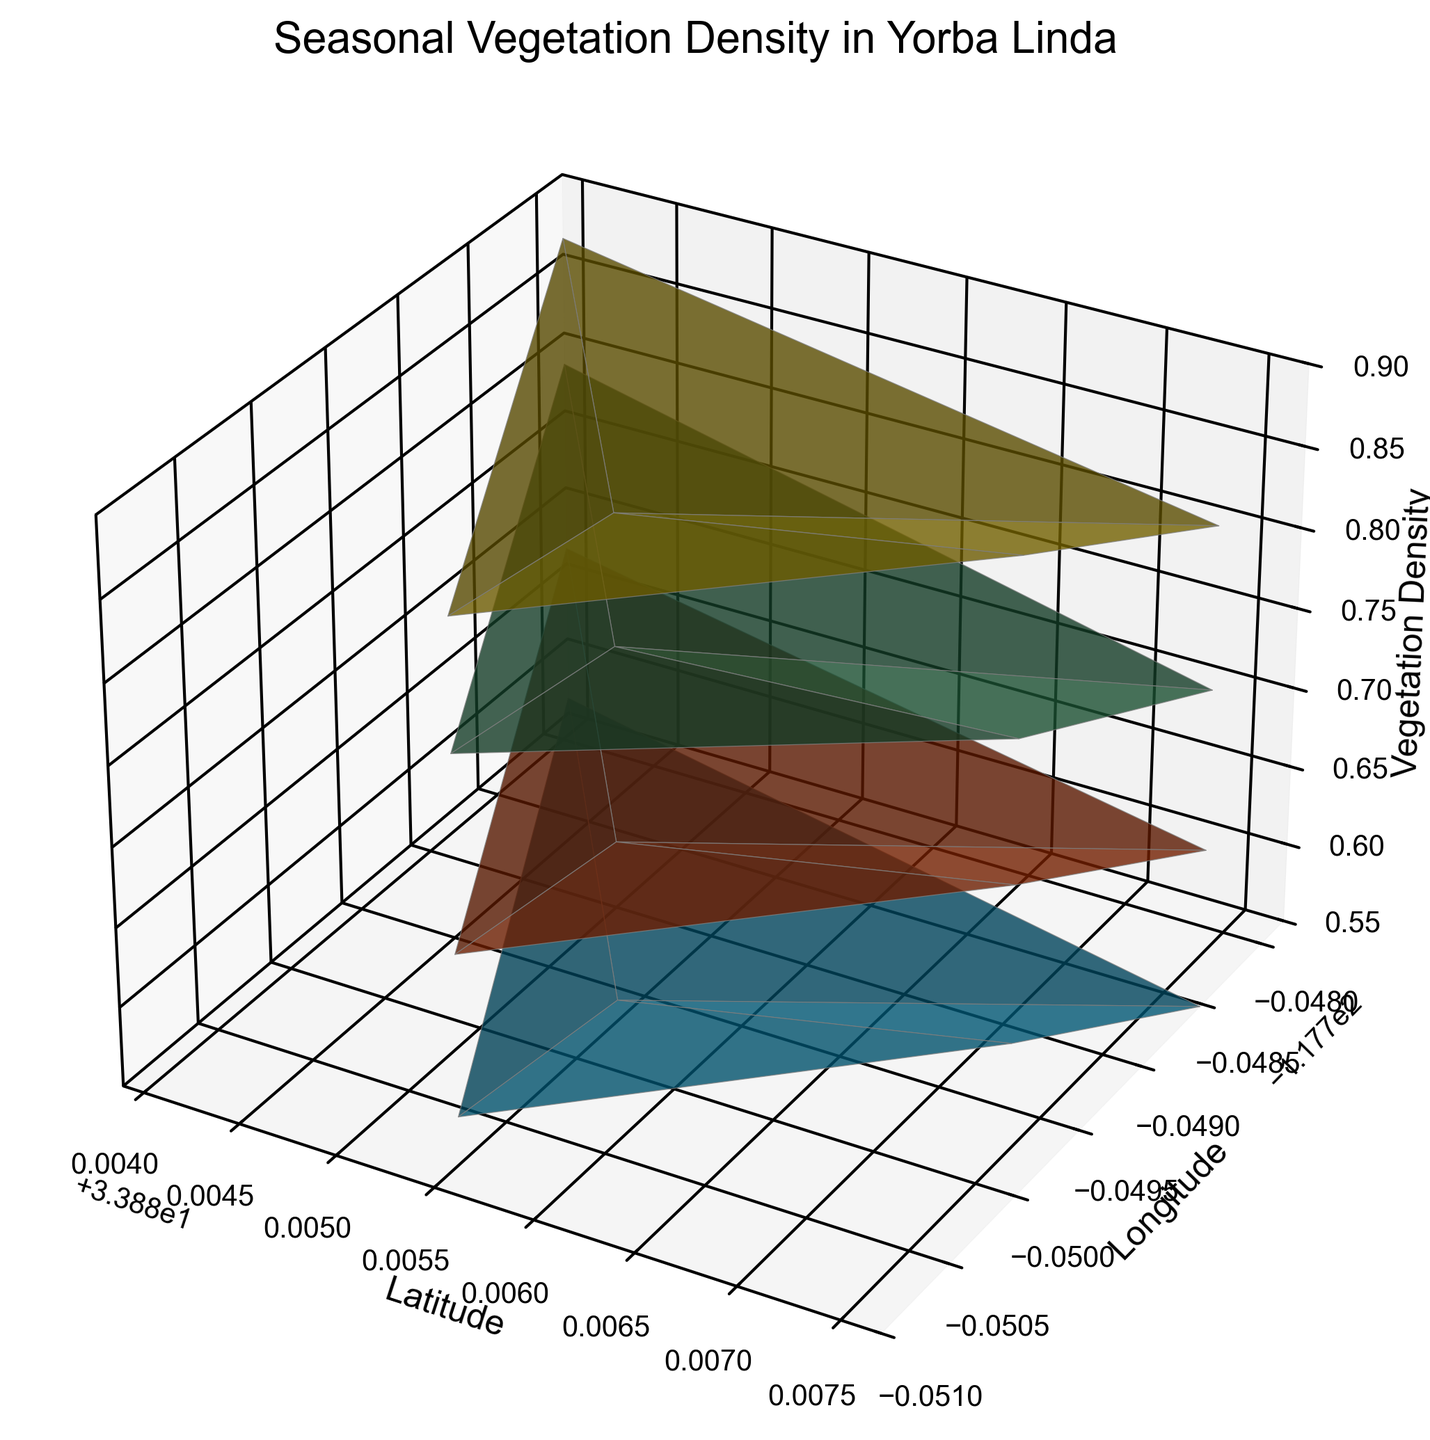How does the vegetation density in Yorba Linda vary between Spring and Winter? Look at the height of the surfaces for Spring and Winter. Spring's vegetation densities range between 0.75 and 0.82, while Winter's densities are lower, ranging from 0.55 to 0.60.
Answer: Spring is higher Which season has the highest vegetation density? Compare the maximum heights of the surfaces of all seasons. Summer has the highest vegetation density with values between 0.85 and 0.90.
Answer: Summer How does the color vary between different seasons in the plot? Notice the plot colors assigned to each season: Spring is green, Summer is yellow, Fall is orange-red, and Winter is blue.
Answer: Different colors are used for each season: green, yellow, orange-red, and blue In which season is the vegetation density the lowest? Identify the lowest point on each surface. Winter has the lowest vegetation density values, ranging from 0.55 to 0.60.
Answer: Winter Comparing Fall and Spring, which season has a greater range of vegetation densities? Calculate the range of vegetation densities for both seasons. Spring ranges from 0.75 to 0.82 (0.07 range), and Fall ranges from 0.65 to 0.70 (0.05 range).
Answer: Spring What is the difference between the highest vegetation density in Summer and the highest in Winter? Identify the highest densities for Summer (0.90) and Winter (0.60) and subtract. 0.90 - 0.60 = 0.30.
Answer: 0.30 Which season shows the most variation in vegetation density across different locations? Determine the range of densities within each season. Summer has a range from 0.85 to 0.90 (0.05), Spring from 0.75 to 0.82 (0.07), Fall from 0.65 to 0.70 (0.05), and Winter from 0.55 to 0.60 (0.05). Spring has the most variation.
Answer: Spring 